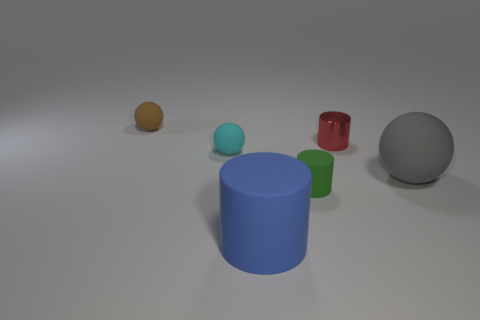How many other red objects have the same shape as the red metallic thing?
Offer a very short reply. 0. Is the number of small green things on the left side of the large blue cylinder the same as the number of objects?
Give a very brief answer. No. The matte object that is the same size as the blue cylinder is what color?
Ensure brevity in your answer.  Gray. Are there any green rubber objects that have the same shape as the tiny brown thing?
Offer a very short reply. No. There is a brown ball on the left side of the tiny cylinder that is right of the tiny cylinder that is in front of the big gray matte thing; what is it made of?
Your answer should be very brief. Rubber. How many other things are there of the same size as the shiny cylinder?
Your answer should be very brief. 3. The small shiny thing is what color?
Give a very brief answer. Red. What number of shiny objects are either big gray things or large cylinders?
Provide a succinct answer. 0. Is there anything else that is the same material as the green thing?
Your answer should be compact. Yes. There is a ball behind the tiny ball to the right of the matte ball behind the red metallic cylinder; how big is it?
Offer a terse response. Small. 